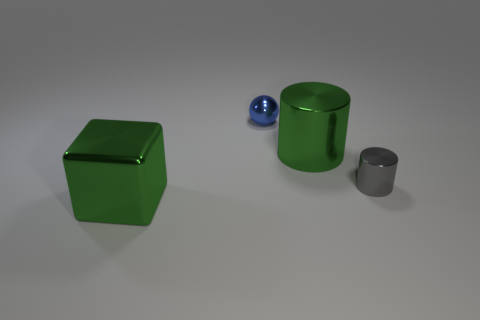Add 2 gray objects. How many objects exist? 6 Add 4 cyan cubes. How many cyan cubes exist? 4 Subtract 0 brown cylinders. How many objects are left? 4 Subtract all small matte cylinders. Subtract all green objects. How many objects are left? 2 Add 3 green metal cubes. How many green metal cubes are left? 4 